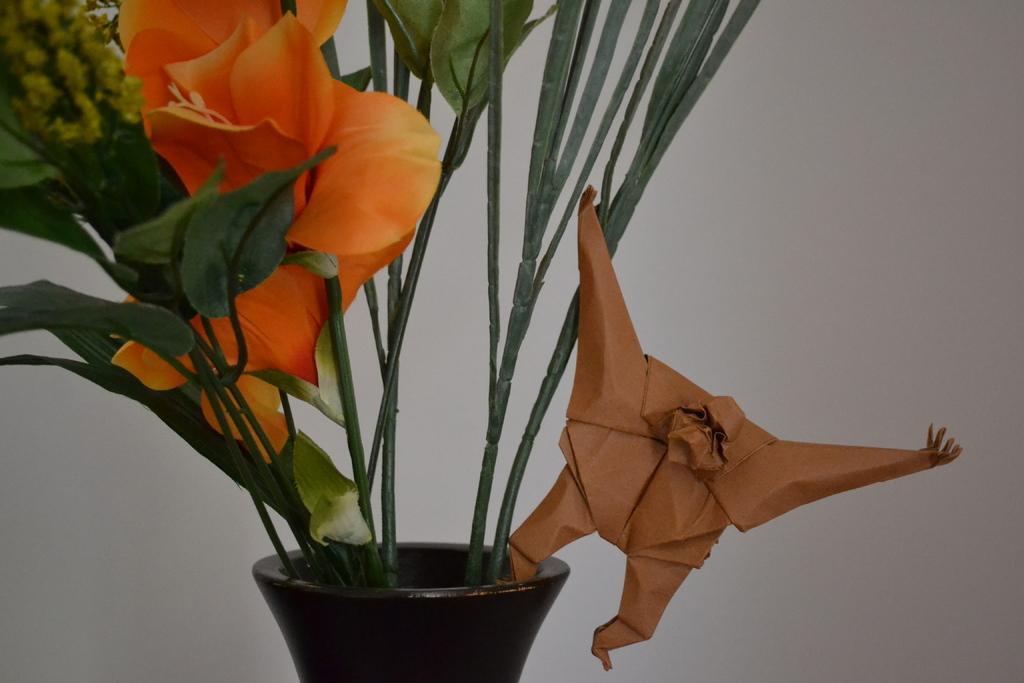Please provide a concise description of this image. In this image, we can see a flower plant with leaves and stems. Here we can see a pot and paper craft. Background there is a white wall. 